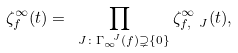<formula> <loc_0><loc_0><loc_500><loc_500>\zeta _ { f } ^ { \infty } ( t ) = \prod _ { { \ J } \colon \Gamma _ { \infty } ^ { \ J } ( f ) \supsetneq \{ 0 \} } \zeta ^ { \infty } _ { f , { \ J } } ( t ) ,</formula> 